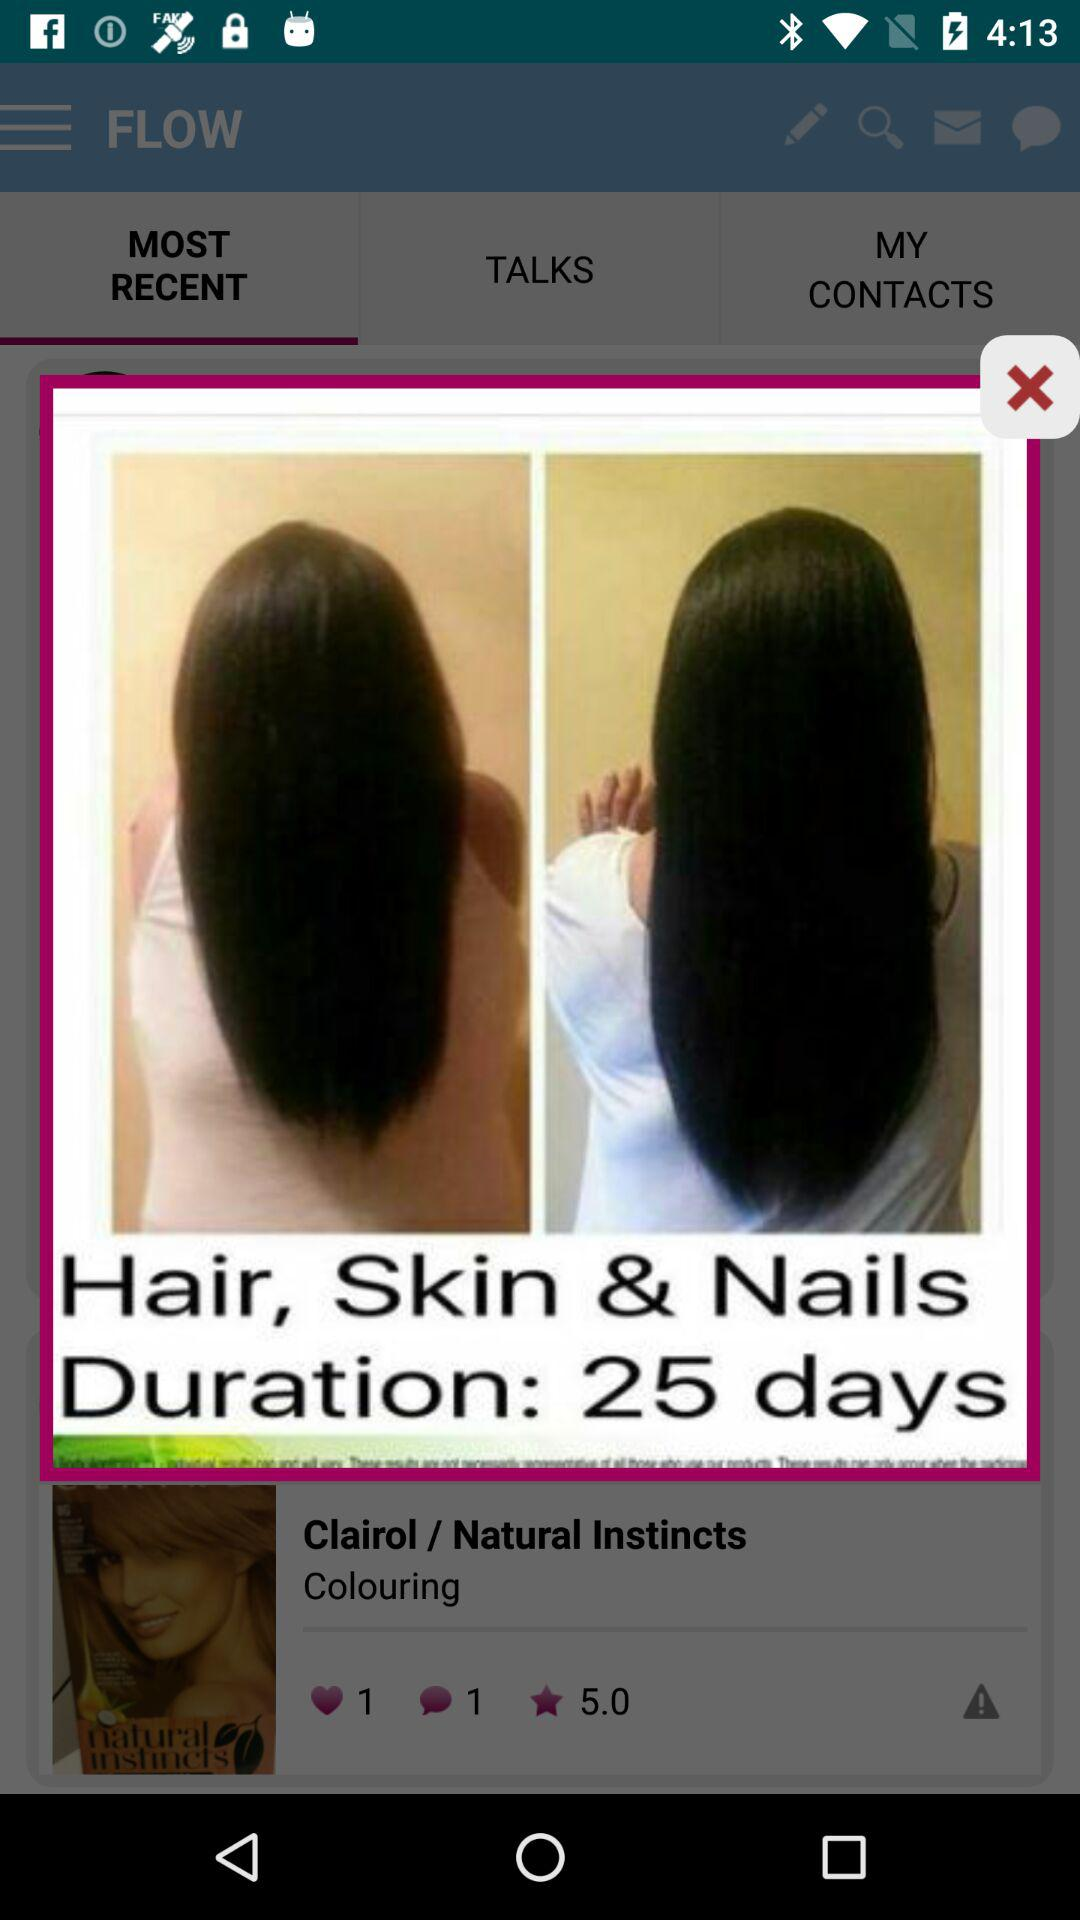How many hearts does the Clairol / Natural Instincts Colouring product have?
Answer the question using a single word or phrase. 1 